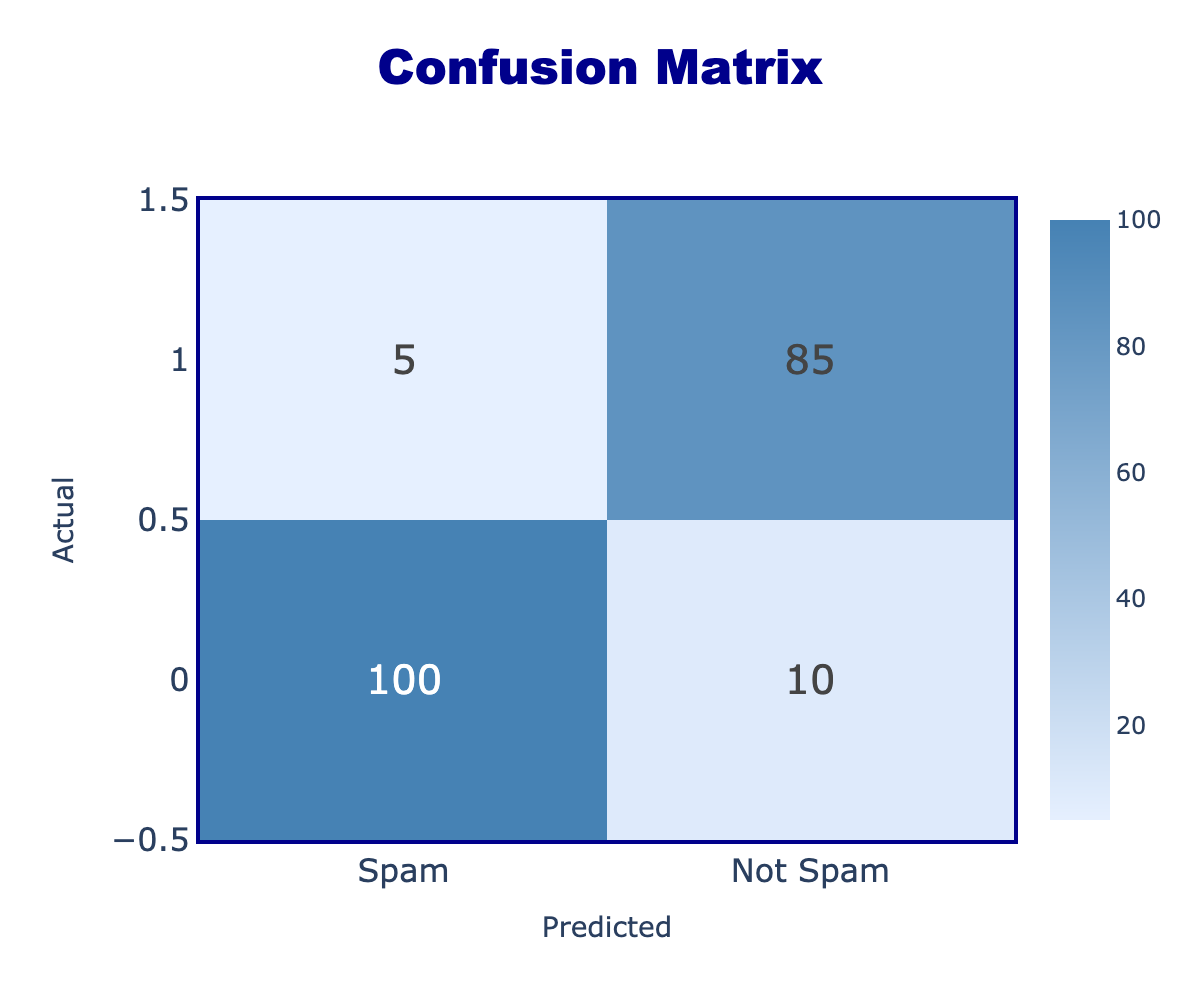What is the number of actual spam emails that were correctly classified as spam? To find this, we look at the intersection of the "Actual" row for "Spam" and the "Predicted" column for "Spam." The table shows that there were 100 emails that were correctly classified as spam.
Answer: 100 How many emails were incorrectly classified as not spam? We look for the "Not Spam" row under the "Spam" column. The value there is 10, which represents the number of spam emails incorrectly classified as not spam.
Answer: 10 What is the total number of actual not spam emails? To find the total actual not spam emails, we must sum the values in the "Not Spam" row: 5 (incorrectly classified spam) + 85 (correctly classified not spam) = 90.
Answer: 90 Are there more correctly classified spam emails than correctly classified not spam emails? We compare the values: 100 correctly classified spam emails versus 85 correctly classified not spam emails. Since 100 is greater than 85, the statement is true.
Answer: Yes What is the total number of emails classified as spam (both correctly and incorrectly)? To find this total, we need to add the numbers under the "Spam" column: 100 (correctly classified spam) + 10 (incorrectly classified spam) + 5 (incorrectly classified not spam) = 115. Hence, the total is 115.
Answer: 115 If we sum the cells for correctly classified emails, what is the total? We sum the values that indicate correct classifications: 100 (correct spam) + 85 (correct not spam) = 185. This gives the total number of correctly classified emails.
Answer: 185 What percentage of actual spam emails were identified correctly? To calculate the percentage of correctly identified spam, we use the formula: (correctly classified spam / total actual spam) * 100. The total actual spam is the sum of correctly classified (100) and incorrectly classified (10), which is 110. So, (100 / 110) * 100 ≈ 90.91%.
Answer: 90.91% How many emails were classified as not spam but were actually spam? This is found in the "Not Spam" row under the "Spam" column, and the value is 5. This indicates the number of emails that were classified as not spam but were actually spam.
Answer: 5 What is the difference in the number of correctly classified spam and not spam emails? We look for correctly classified spam (100) and correctly classified not spam (85). The difference is 100 - 85 = 15, indicating that more spam emails were classified correctly compared to not spam emails.
Answer: 15 